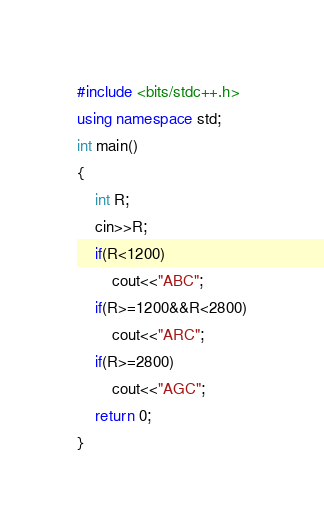<code> <loc_0><loc_0><loc_500><loc_500><_C++_>#include <bits/stdc++.h>
using namespace std;
int main()
{
	int R;
	cin>>R;
	if(R<1200)
		cout<<"ABC";
	if(R>=1200&&R<2800)
		cout<<"ARC";
	if(R>=2800)
		cout<<"AGC"; 
	return 0;
}</code> 